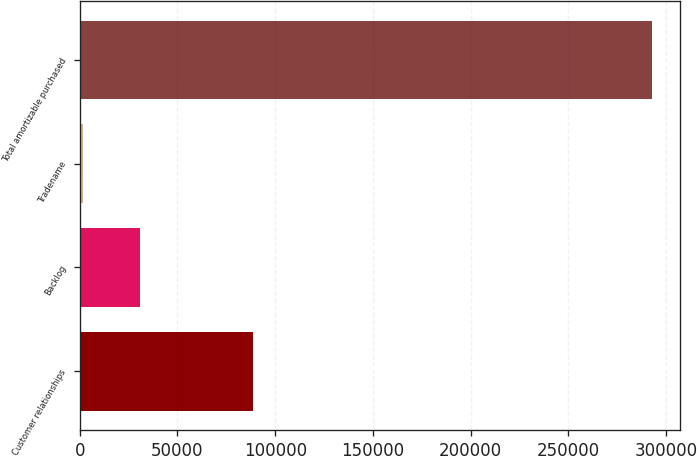Convert chart to OTSL. <chart><loc_0><loc_0><loc_500><loc_500><bar_chart><fcel>Customer relationships<fcel>Backlog<fcel>Tradename<fcel>Total amortizable purchased<nl><fcel>88630<fcel>30794.2<fcel>1700<fcel>292642<nl></chart> 